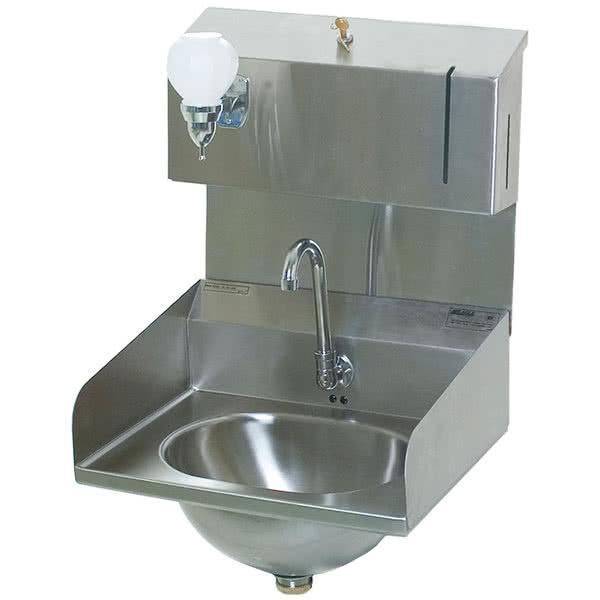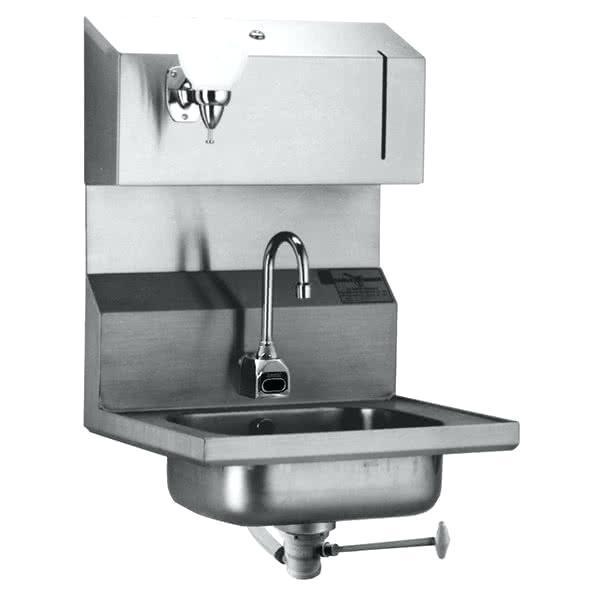The first image is the image on the left, the second image is the image on the right. Considering the images on both sides, is "The left and right image contains the same number of  hanging sinks." valid? Answer yes or no. Yes. The first image is the image on the left, the second image is the image on the right. Considering the images on both sides, is "There are two sinks, and none of them have legs." valid? Answer yes or no. Yes. 